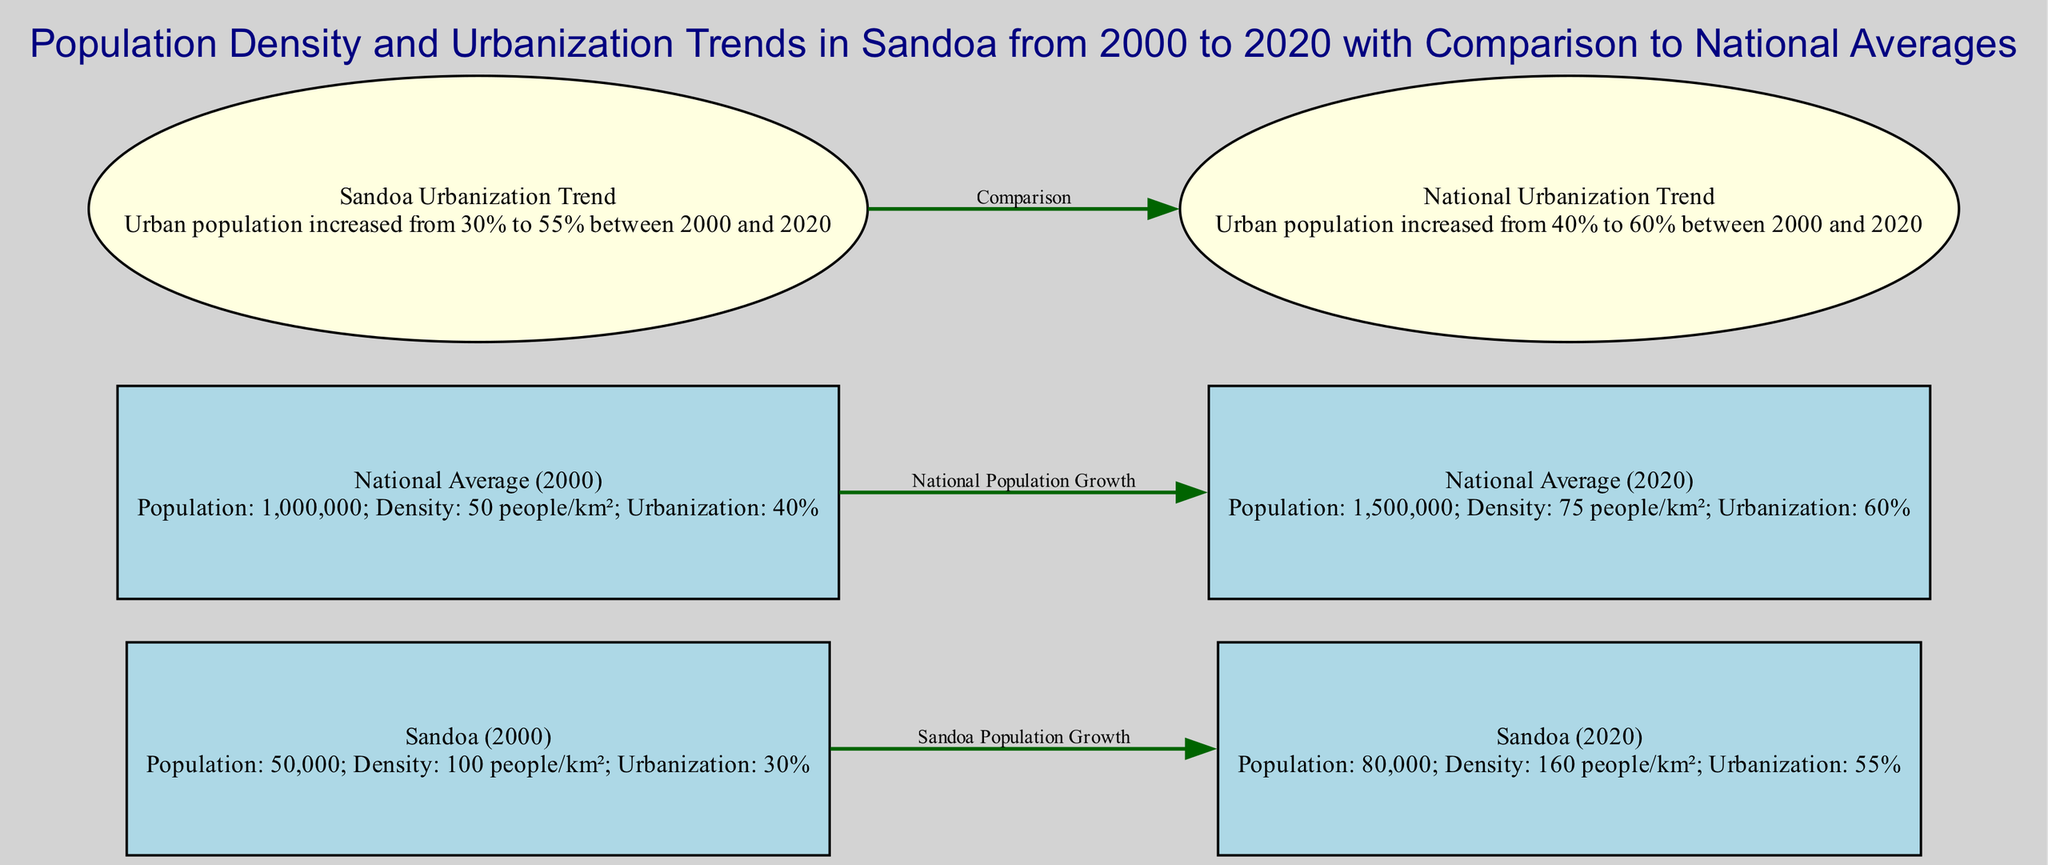What was the population of Sandoa in 2000? The diagram states that the population of Sandoa in 2000 was 50,000 people.
Answer: 50,000 What was the urbanization percentage in Sandoa in 2020? According to the information for Sandoa in 2020, the urbanization rate was 55%.
Answer: 55% How much did the population of Sandoa increase between 2000 and 2020? The edge labeled "Sandoa Population Growth" indicates a 30,000 increase in population from 50,000 in 2000 to 80,000 in 2020.
Answer: 30,000 What was the population density of Sandoa in 2020? The diagram shows that the population density of Sandoa in 2020 was 160 people per km².
Answer: 160 people/km² Which year had a higher urbanization percentage, Sandoa in 2020 or national average in 2000? In 2020, Sandoa had an urbanization percentage of 55%, while the national average in 2000 was 40%. Therefore, Sandoa's urbanization percentage is higher than the national average from 2000.
Answer: Sandoa (2020) What was the change in national population density from 2000 to 2020? The density for the national average increased from 50 people per km² in 2000 to 75 people per km² in 2020, resulting in a change of 25 people per km².
Answer: 25 people/km² Which location saw a greater increase in urbanization from 2000 to 2020? Sandoa had an increase from 30% to 55%, which is a 25% increase, while the national average increased from 40% to 60%, which is a 20% increase. Sandoa therefore had a greater increase in urbanization.
Answer: Sandoa How many nodes represent the year 2020 in the diagram? The diagram contains two nodes representing the year 2020: "Sandoa (2020)" and "National Average (2020)", thus there are a total of two.
Answer: 2 What type of graph is being represented? The diagram represents a social science diagram focused on population density and urbanization trends.
Answer: Social Science Diagram 